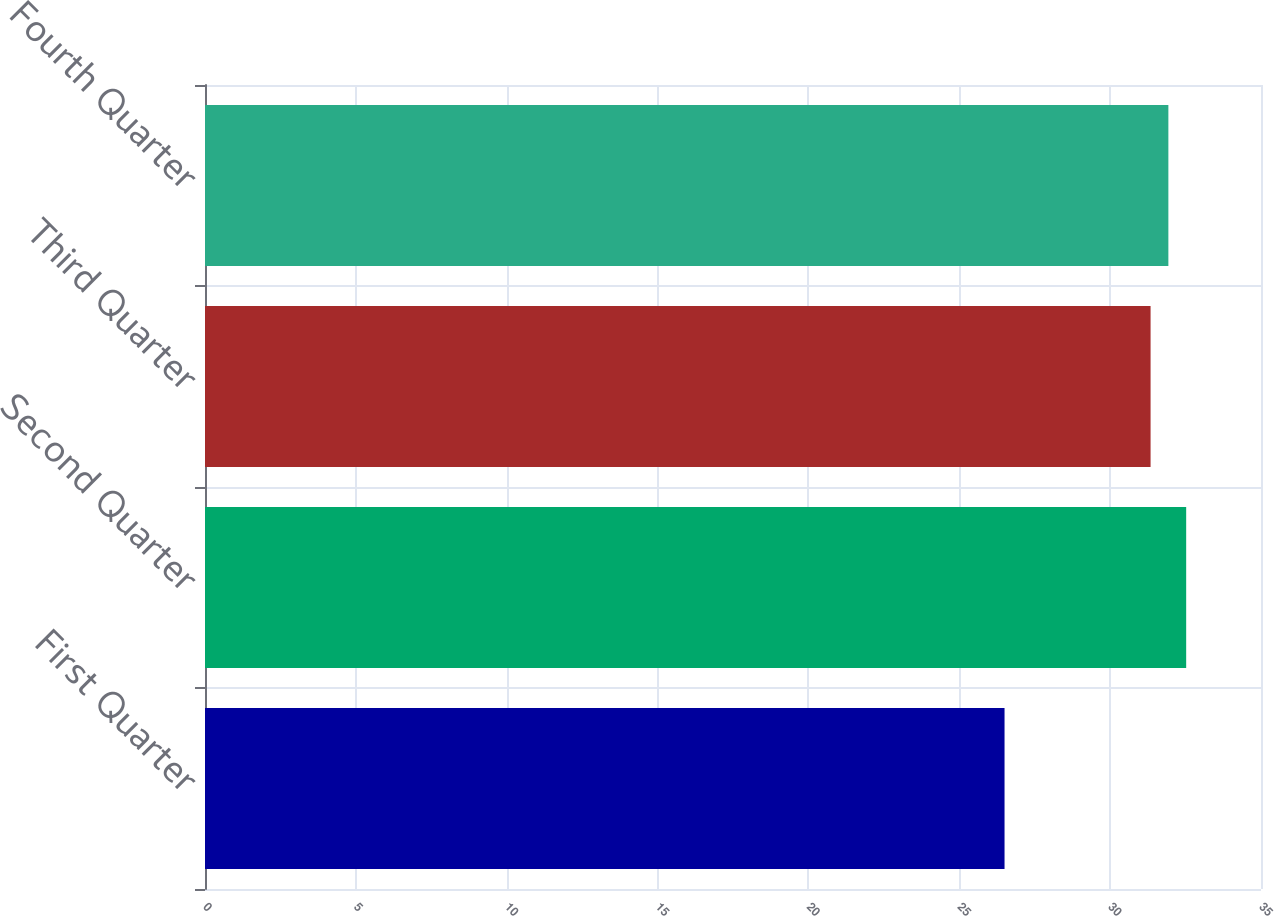Convert chart to OTSL. <chart><loc_0><loc_0><loc_500><loc_500><bar_chart><fcel>First Quarter<fcel>Second Quarter<fcel>Third Quarter<fcel>Fourth Quarter<nl><fcel>26.5<fcel>32.52<fcel>31.34<fcel>31.93<nl></chart> 